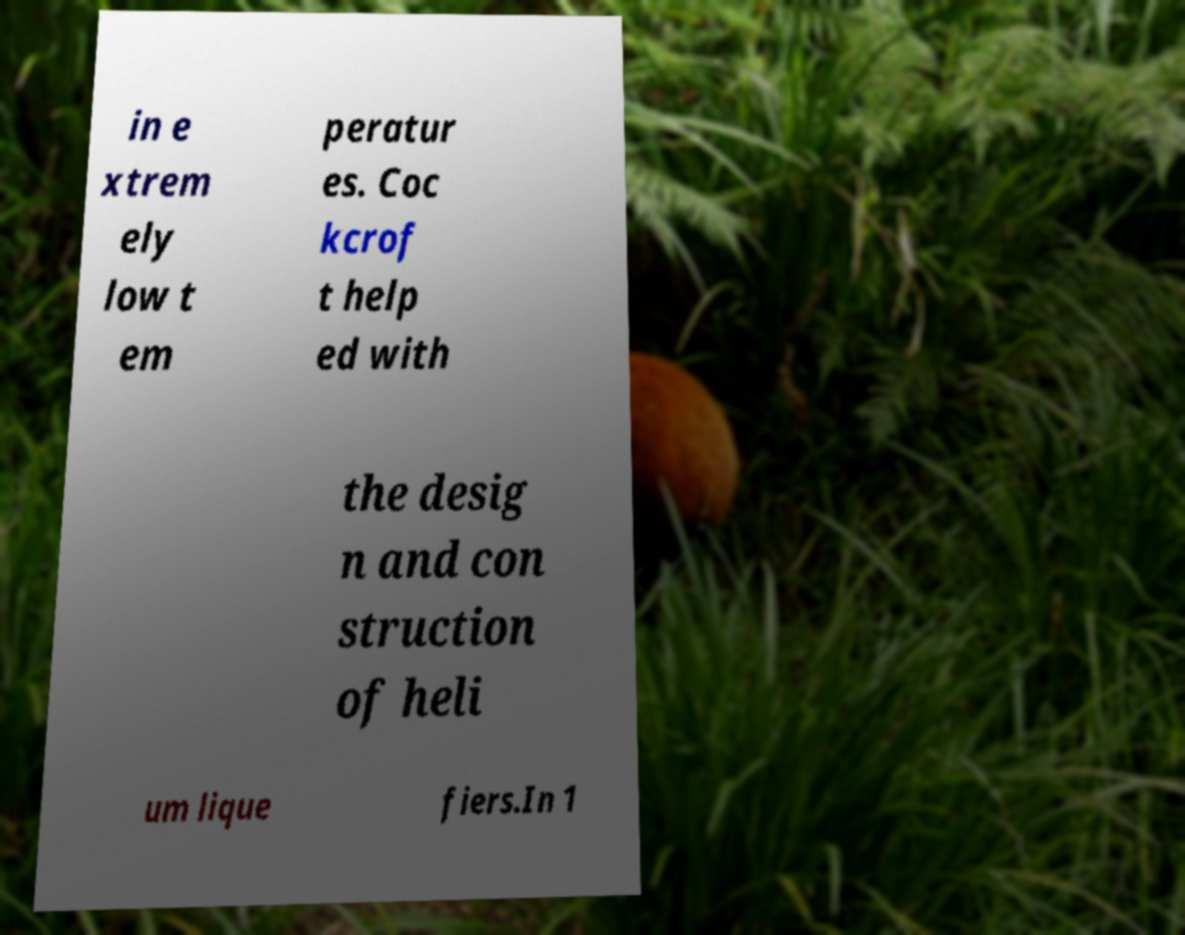Could you extract and type out the text from this image? in e xtrem ely low t em peratur es. Coc kcrof t help ed with the desig n and con struction of heli um lique fiers.In 1 